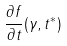<formula> <loc_0><loc_0><loc_500><loc_500>\frac { \partial f } { \partial t } ( \gamma , t ^ { * } )</formula> 